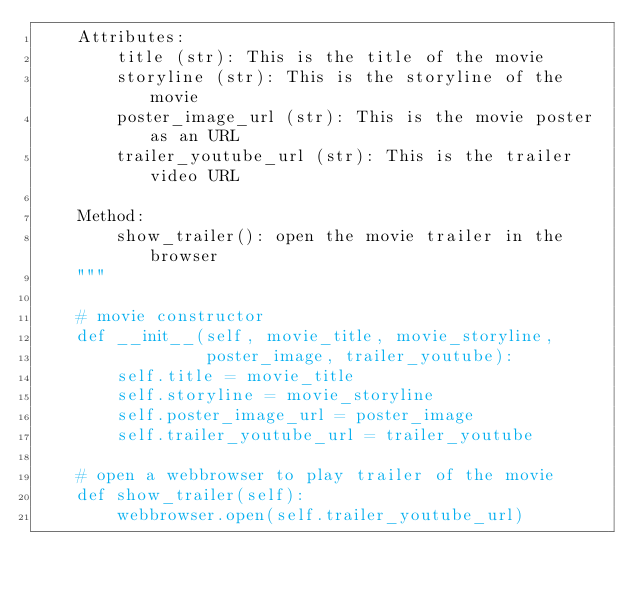<code> <loc_0><loc_0><loc_500><loc_500><_Python_>    Attributes:
        title (str): This is the title of the movie
        storyline (str): This is the storyline of the movie
        poster_image_url (str): This is the movie poster as an URL
        trailer_youtube_url (str): This is the trailer video URL

    Method:
        show_trailer(): open the movie trailer in the browser
    """

    # movie constructor
    def __init__(self, movie_title, movie_storyline,
                 poster_image, trailer_youtube):
        self.title = movie_title
        self.storyline = movie_storyline
        self.poster_image_url = poster_image
        self.trailer_youtube_url = trailer_youtube

    # open a webbrowser to play trailer of the movie
    def show_trailer(self):
        webbrowser.open(self.trailer_youtube_url)
</code> 